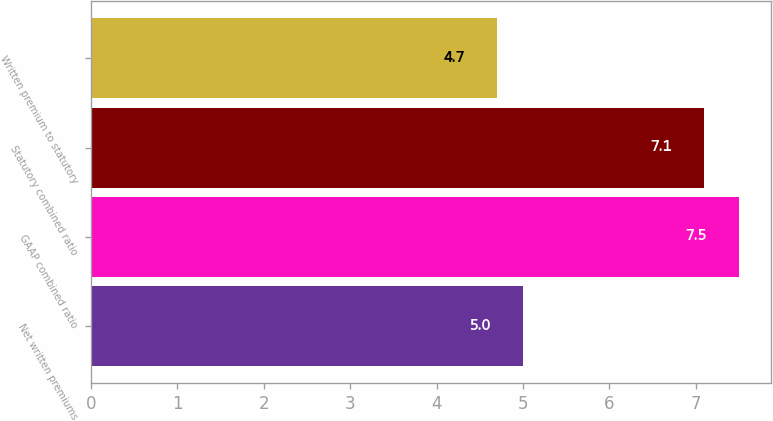Convert chart to OTSL. <chart><loc_0><loc_0><loc_500><loc_500><bar_chart><fcel>Net written premiums<fcel>GAAP combined ratio<fcel>Statutory combined ratio<fcel>Written premium to statutory<nl><fcel>5<fcel>7.5<fcel>7.1<fcel>4.7<nl></chart> 